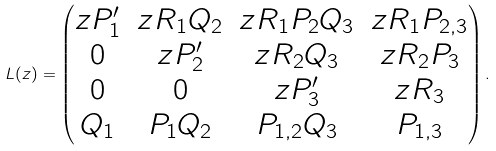<formula> <loc_0><loc_0><loc_500><loc_500>L ( z ) = \begin{pmatrix} z P ^ { \prime } _ { 1 } & z R _ { 1 } Q _ { 2 } & z R _ { 1 } P _ { 2 } Q _ { 3 } & z R _ { 1 } P _ { 2 , 3 } \\ 0 & z P ^ { \prime } _ { 2 } & z R _ { 2 } Q _ { 3 } & z R _ { 2 } P _ { 3 } \\ 0 & 0 & z P ^ { \prime } _ { 3 } & z R _ { 3 } \\ Q _ { 1 } & P _ { 1 } Q _ { 2 } & P _ { 1 , 2 } Q _ { 3 } & P _ { 1 , 3 } \end{pmatrix} .</formula> 